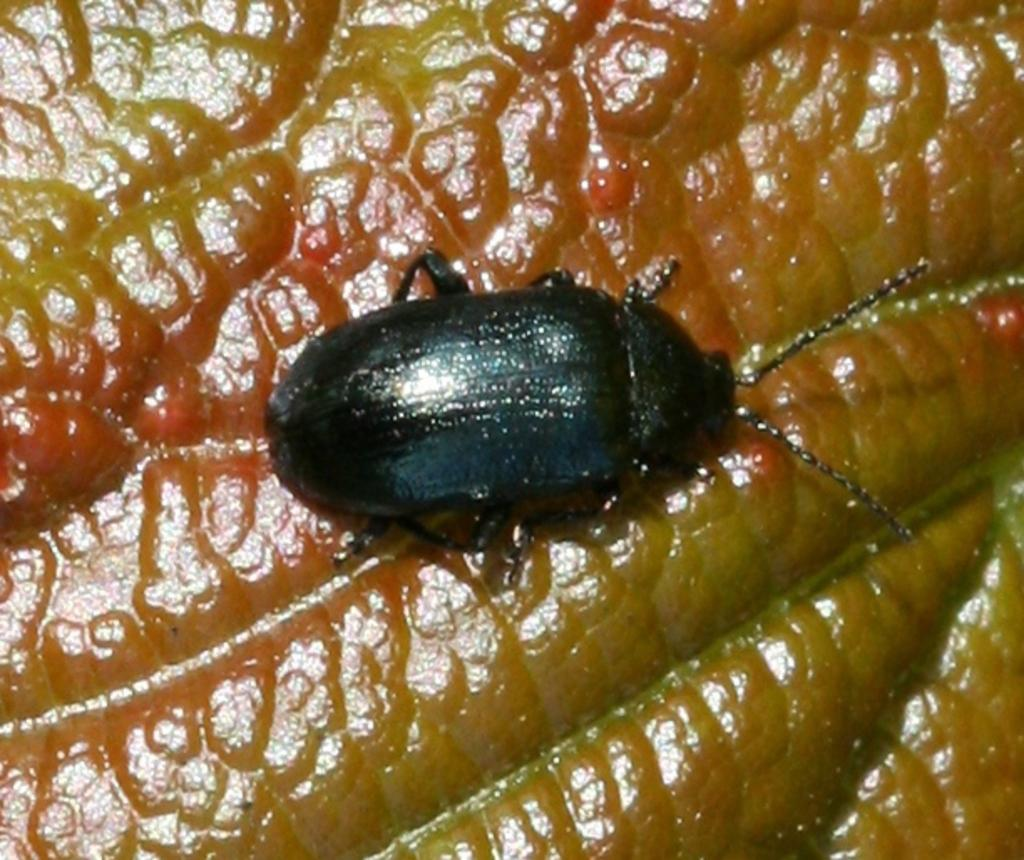What type of insect is present in the image? There is a black bug in the image. What is the bug doing in the image? The bug is sitting on a brown object. What type of soup is the bug stirring in the image? There is no soup present in the image; the bug is sitting on a brown object. 